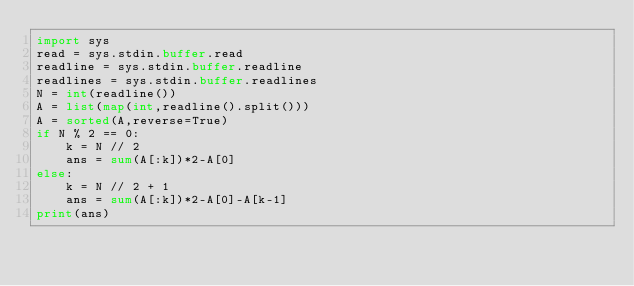<code> <loc_0><loc_0><loc_500><loc_500><_Python_>import sys 
read = sys.stdin.buffer.read
readline = sys.stdin.buffer.readline
readlines = sys.stdin.buffer.readlines
N = int(readline())
A = list(map(int,readline().split()))
A = sorted(A,reverse=True)
if N % 2 == 0: 
    k = N // 2
    ans = sum(A[:k])*2-A[0]
else:
    k = N // 2 + 1
    ans = sum(A[:k])*2-A[0]-A[k-1]
print(ans)</code> 